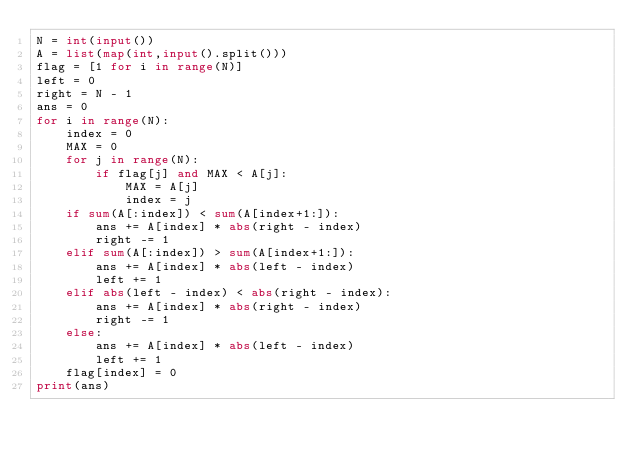Convert code to text. <code><loc_0><loc_0><loc_500><loc_500><_Python_>N = int(input())
A = list(map(int,input().split()))
flag = [1 for i in range(N)]
left = 0
right = N - 1
ans = 0
for i in range(N):
    index = 0
    MAX = 0
    for j in range(N):
        if flag[j] and MAX < A[j]:
            MAX = A[j]
            index = j
    if sum(A[:index]) < sum(A[index+1:]):
        ans += A[index] * abs(right - index)
        right -= 1
    elif sum(A[:index]) > sum(A[index+1:]):
        ans += A[index] * abs(left - index)
        left += 1
    elif abs(left - index) < abs(right - index):
        ans += A[index] * abs(right - index)
        right -= 1
    else:
        ans += A[index] * abs(left - index)
        left += 1
    flag[index] = 0
print(ans)</code> 